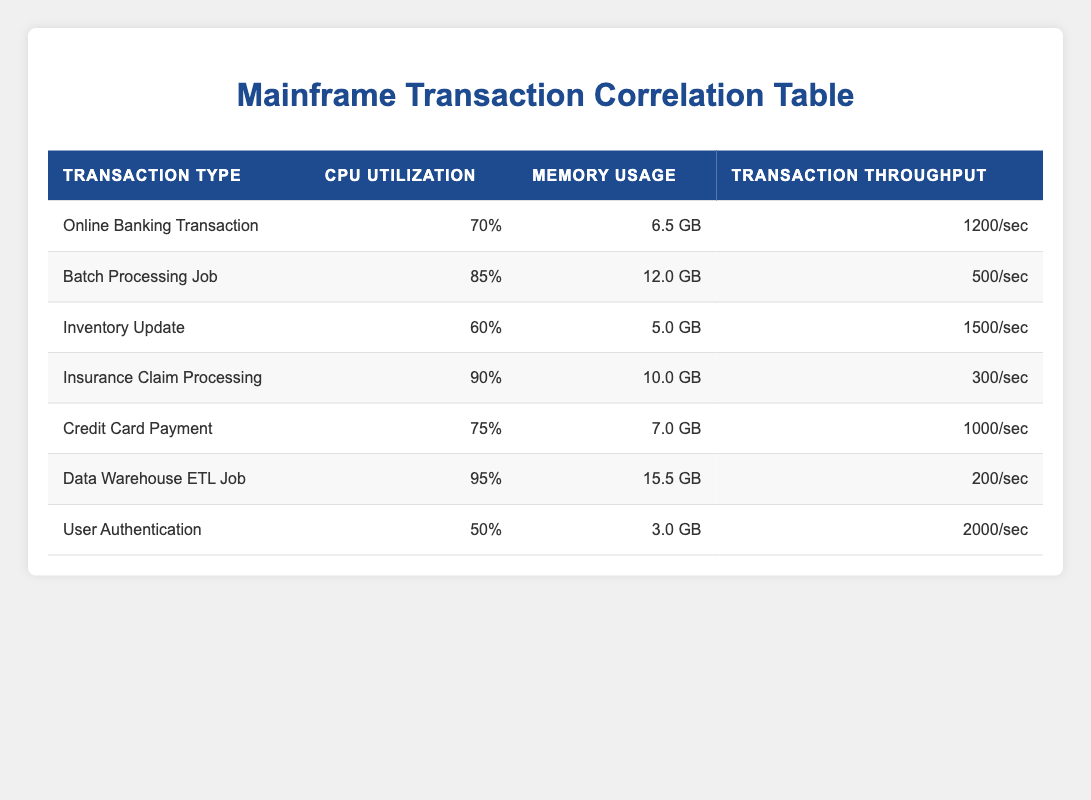What is the CPU utilization for the Online Banking Transaction? The table shows the CPU utilization for the Online Banking Transaction is listed under the relevant row, which is 70.
Answer: 70 Which transaction type has the highest transaction throughput? By examining the transaction throughput values for each transaction type, the User Authentication has the highest transaction throughput of 2000.
Answer: User Authentication What is the difference in memory usage between the Batch Processing Job and the Inventory Update? The memory usage for the Batch Processing Job is 12.0 GB, and for the Inventory Update, it is 5.0 GB. The difference is 12.0 - 5.0 = 7.0 GB.
Answer: 7.0 GB Is the CPU utilization for the Data Warehouse ETL Job above 90%? The CPU utilization for the Data Warehouse ETL Job is 95%, which is indeed above 90%.
Answer: Yes What is the average transaction throughput for the transactions with CPU utilization above 80%? The transactions with CPU utilization above 80% are: Batch Processing Job (500), Insurance Claim Processing (300), and Data Warehouse ETL Job (200). Summing these gives 500 + 300 + 200 = 1000. Dividing by 3 gives an average of 1000 / 3 = approximately 333.33.
Answer: Approximately 333.33 How many transactions have a memory usage greater than 10 GB? Analyzing the memory usage column, only the Batch Processing Job (12.0 GB) and Data Warehouse ETL Job (15.5 GB) are greater than 10 GB, totaling 2 transactions.
Answer: 2 What is the total transaction throughput for all transaction types listed? To find the total transaction throughput, sum up all throughput values: 1200 + 500 + 1500 + 300 + 1000 + 200 + 2000 = 5700.
Answer: 5700 Does any transaction type have a CPU utilization below 60%? The data shows that the User Authentication has a CPU utilization of 50%, which is below 60%.
Answer: Yes 